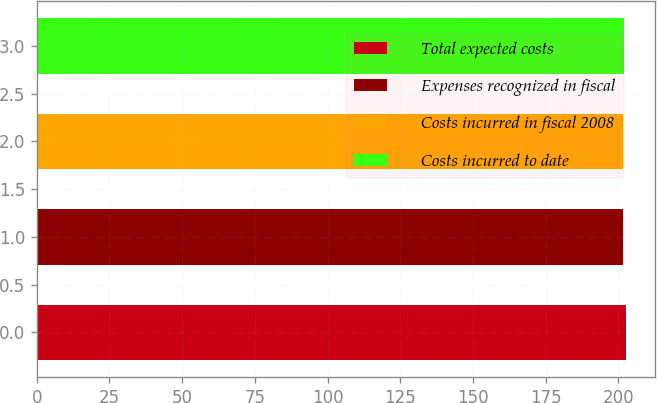<chart> <loc_0><loc_0><loc_500><loc_500><bar_chart><fcel>Total expected costs<fcel>Expenses recognized in fiscal<fcel>Costs incurred in fiscal 2008<fcel>Costs incurred to date<nl><fcel>202.5<fcel>201.6<fcel>201.69<fcel>201.78<nl></chart> 